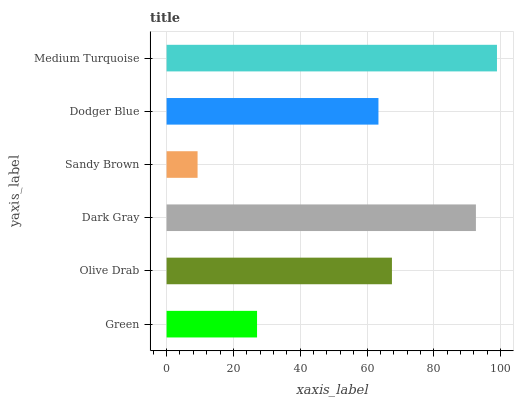Is Sandy Brown the minimum?
Answer yes or no. Yes. Is Medium Turquoise the maximum?
Answer yes or no. Yes. Is Olive Drab the minimum?
Answer yes or no. No. Is Olive Drab the maximum?
Answer yes or no. No. Is Olive Drab greater than Green?
Answer yes or no. Yes. Is Green less than Olive Drab?
Answer yes or no. Yes. Is Green greater than Olive Drab?
Answer yes or no. No. Is Olive Drab less than Green?
Answer yes or no. No. Is Olive Drab the high median?
Answer yes or no. Yes. Is Dodger Blue the low median?
Answer yes or no. Yes. Is Green the high median?
Answer yes or no. No. Is Sandy Brown the low median?
Answer yes or no. No. 